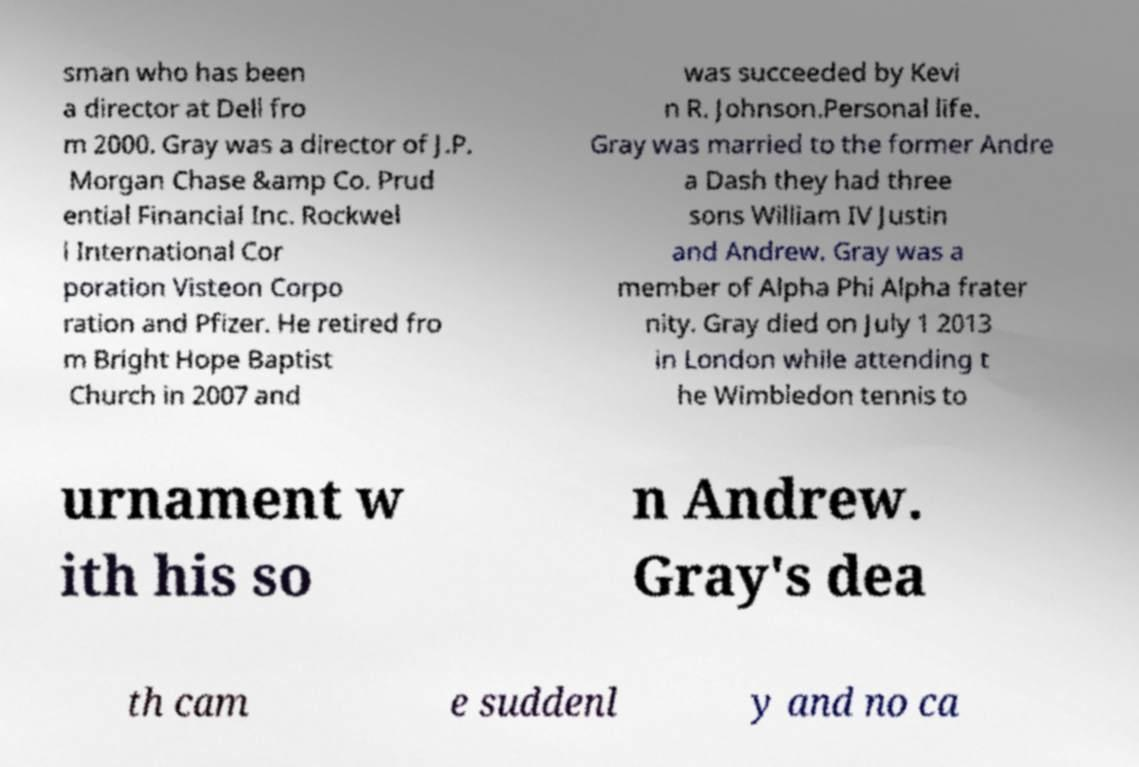Please identify and transcribe the text found in this image. sman who has been a director at Dell fro m 2000. Gray was a director of J.P. Morgan Chase &amp Co. Prud ential Financial Inc. Rockwel l International Cor poration Visteon Corpo ration and Pfizer. He retired fro m Bright Hope Baptist Church in 2007 and was succeeded by Kevi n R. Johnson.Personal life. Gray was married to the former Andre a Dash they had three sons William IV Justin and Andrew. Gray was a member of Alpha Phi Alpha frater nity. Gray died on July 1 2013 in London while attending t he Wimbledon tennis to urnament w ith his so n Andrew. Gray's dea th cam e suddenl y and no ca 